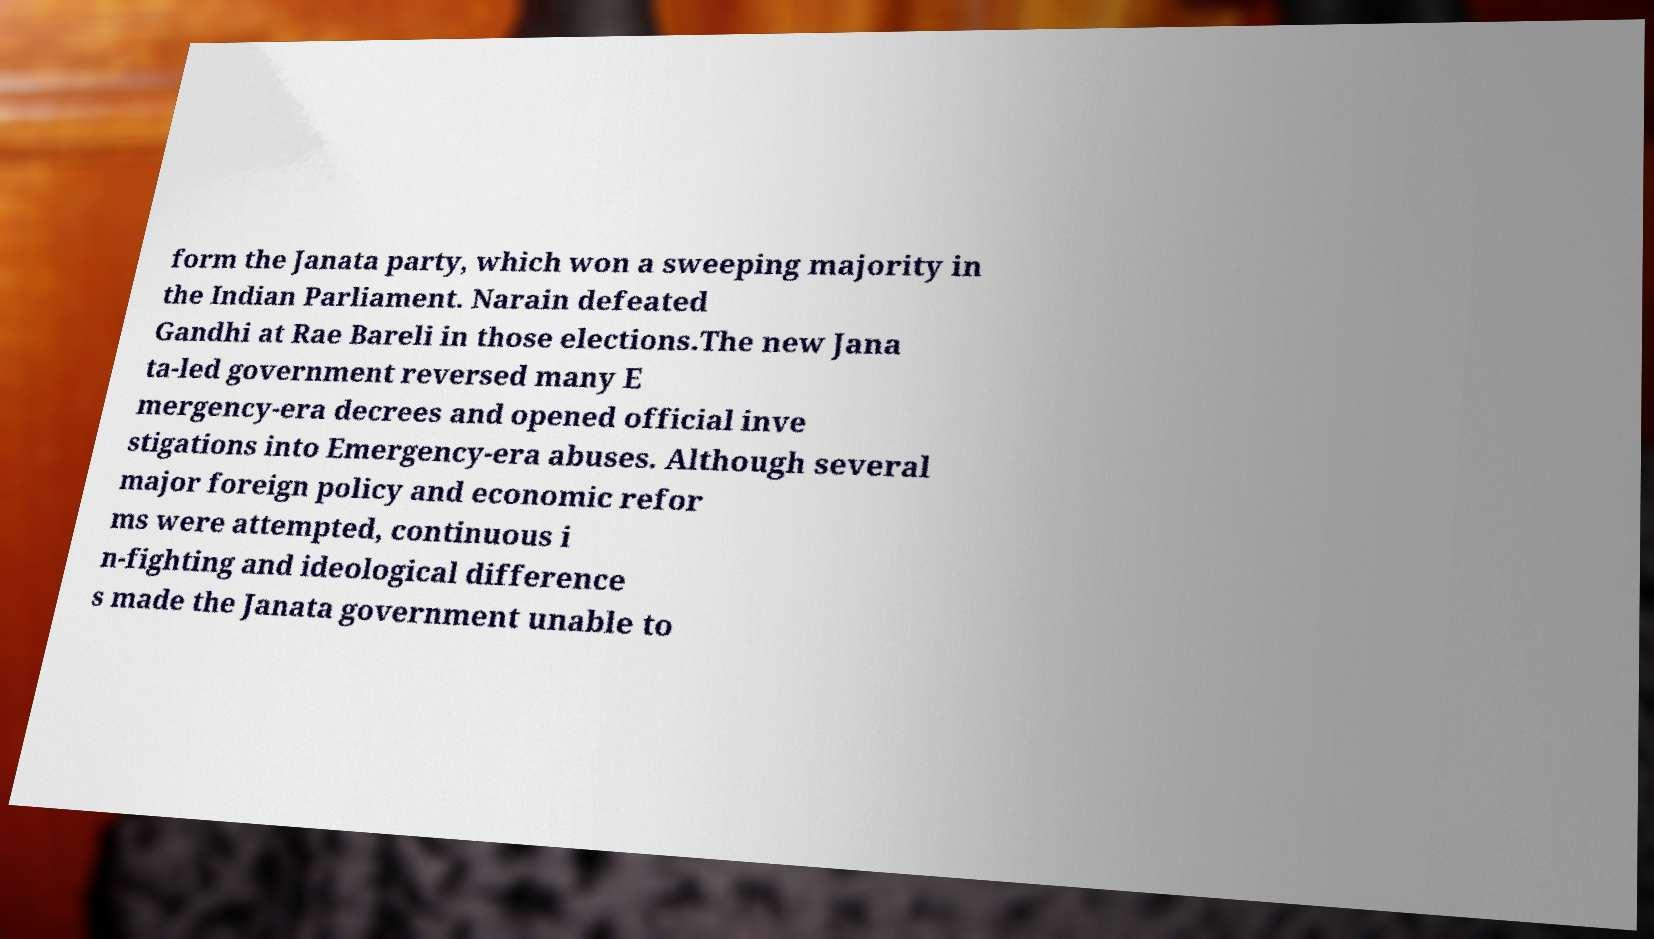Could you extract and type out the text from this image? form the Janata party, which won a sweeping majority in the Indian Parliament. Narain defeated Gandhi at Rae Bareli in those elections.The new Jana ta-led government reversed many E mergency-era decrees and opened official inve stigations into Emergency-era abuses. Although several major foreign policy and economic refor ms were attempted, continuous i n-fighting and ideological difference s made the Janata government unable to 